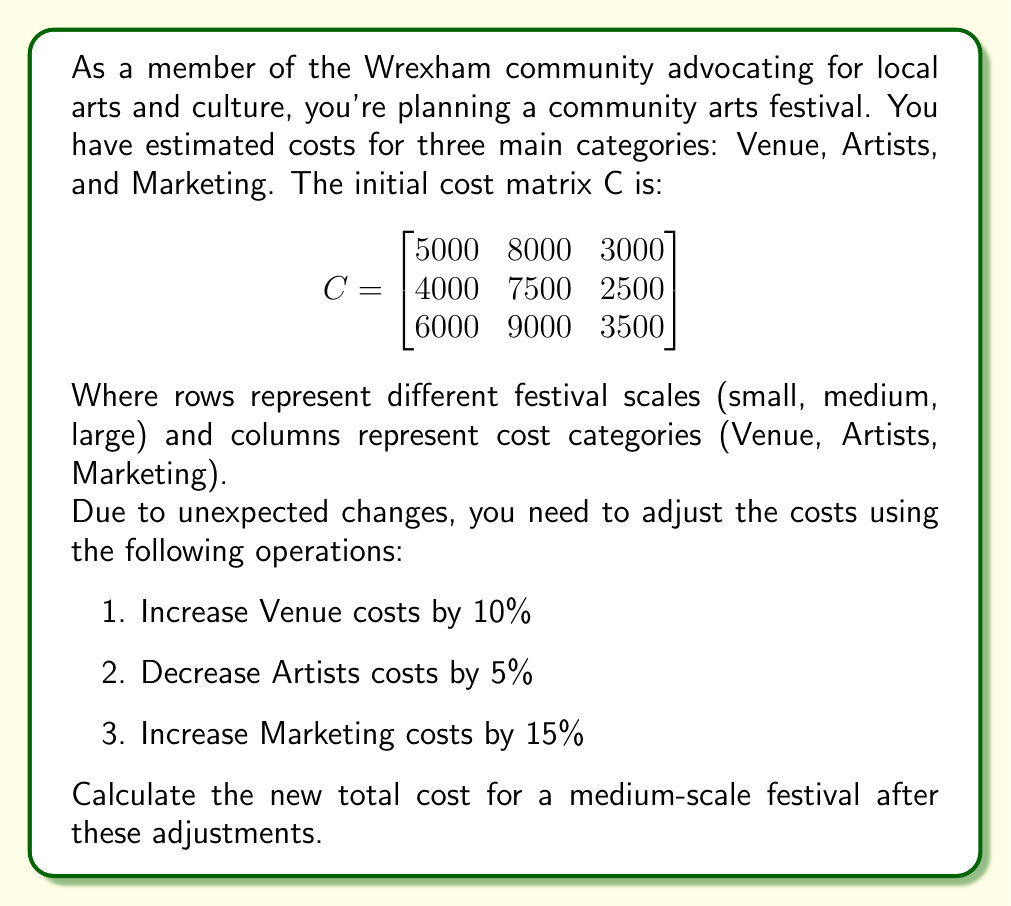Teach me how to tackle this problem. Let's approach this step-by-step:

1) First, we need to create a matrix to represent the percentage changes:

   $$P = \begin{bmatrix}
   1.10 & 0.95 & 1.15
   \end{bmatrix}$$

2) To apply these changes, we need to multiply each column of the original matrix by the corresponding percentage in P. We can do this using matrix multiplication:

   $$C_{new} = C \cdot diag(P)$$

   Where diag(P) is a diagonal matrix with the elements of P on its main diagonal.

3) Let's calculate this:

   $$C_{new} = \begin{bmatrix}
   5000 & 8000 & 3000 \\
   4000 & 7500 & 2500 \\
   6000 & 9000 & 3500
   \end{bmatrix} \cdot \begin{bmatrix}
   1.10 & 0 & 0 \\
   0 & 0.95 & 0 \\
   0 & 0 & 1.15
   \end{bmatrix}$$

4) Performing the matrix multiplication:

   $$C_{new} = \begin{bmatrix}
   5500 & 7600 & 3450 \\
   4400 & 7125 & 2875 \\
   6600 & 8550 & 4025
   \end{bmatrix}$$

5) The question asks for the total cost of a medium-scale festival. This corresponds to the second row of our new matrix:

   $[4400 \quad 7125 \quad 2875]$

6) To get the total, we sum these values:

   $4400 + 7125 + 2875 = 14400$

Therefore, the new total cost for a medium-scale festival after adjustments is £14,400.
Answer: £14,400 